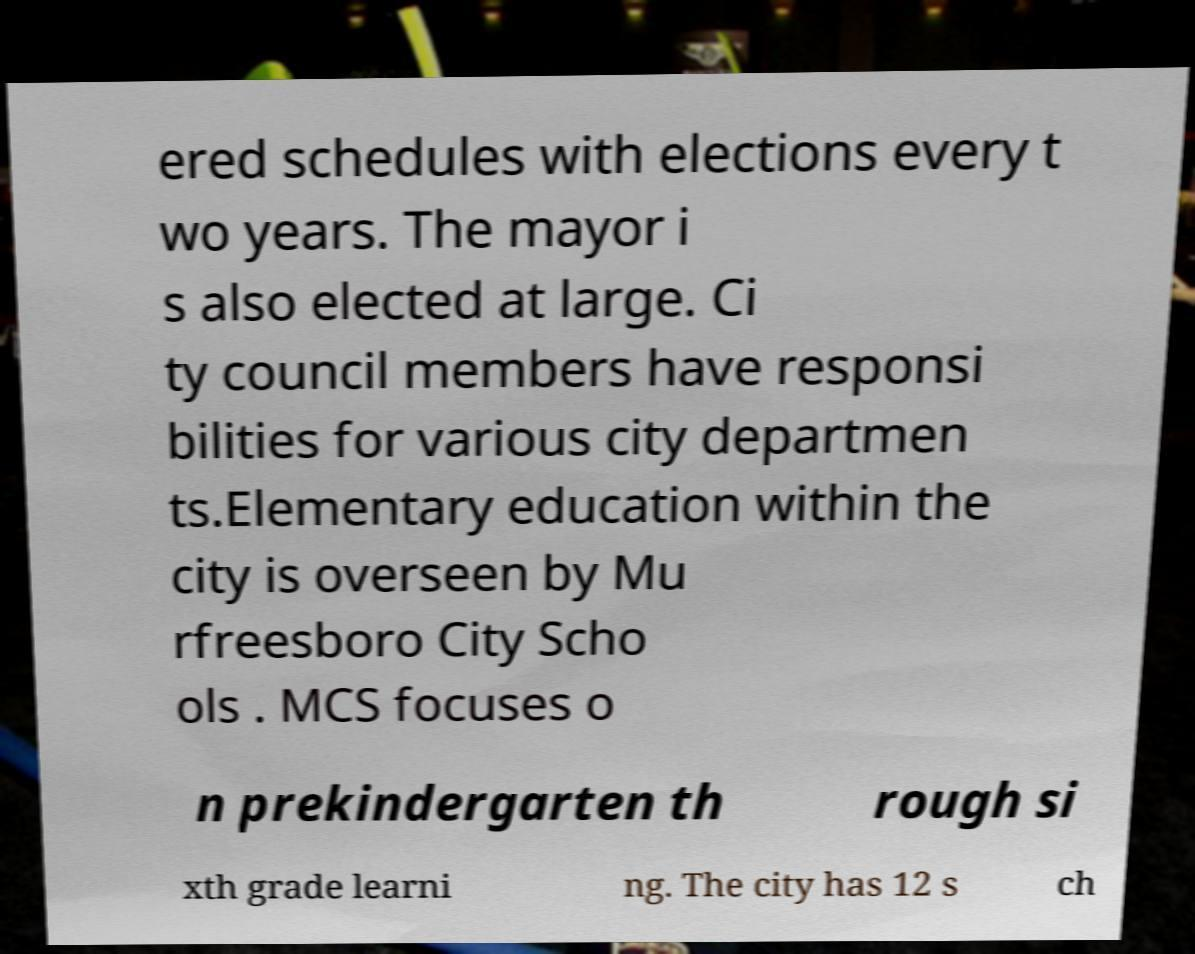Please read and relay the text visible in this image. What does it say? ered schedules with elections every t wo years. The mayor i s also elected at large. Ci ty council members have responsi bilities for various city departmen ts.Elementary education within the city is overseen by Mu rfreesboro City Scho ols . MCS focuses o n prekindergarten th rough si xth grade learni ng. The city has 12 s ch 